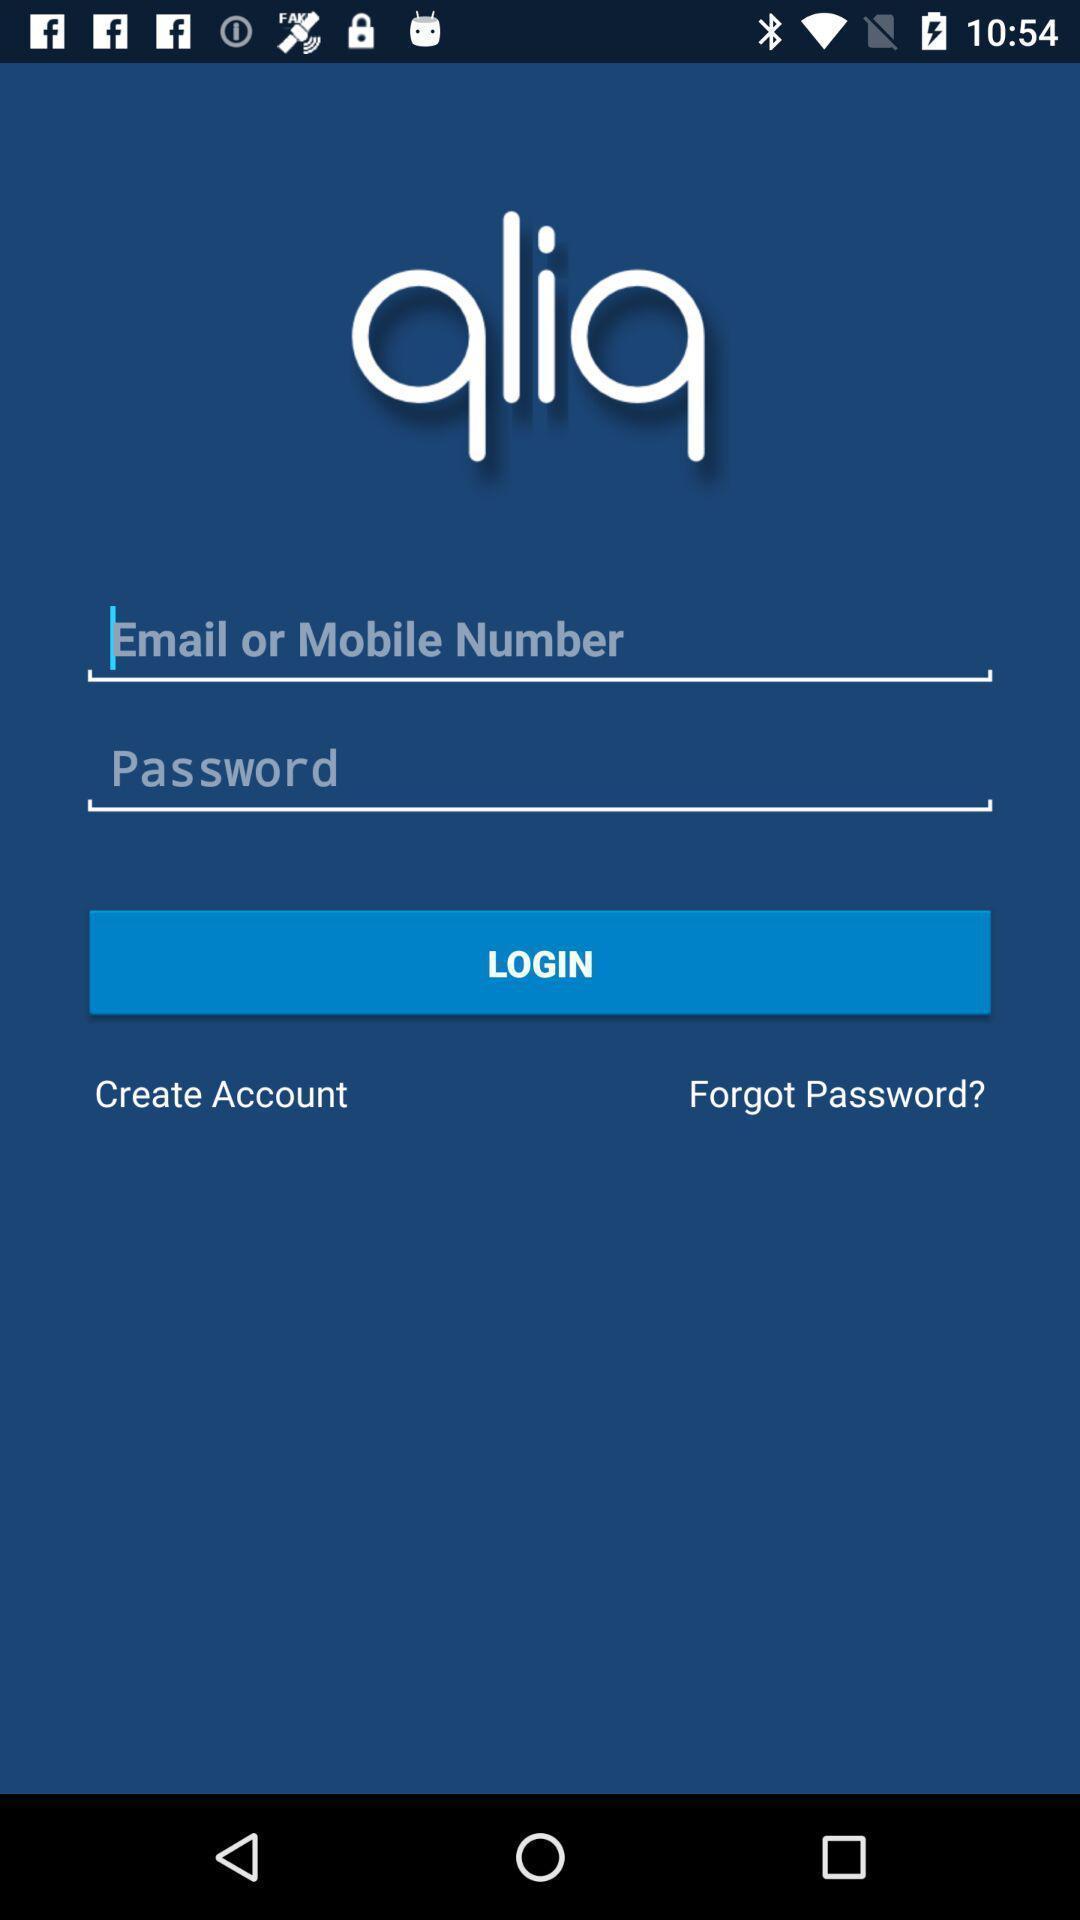Explain what's happening in this screen capture. Login page. 